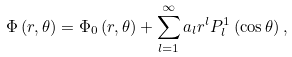<formula> <loc_0><loc_0><loc_500><loc_500>\Phi \left ( r , \theta \right ) = \Phi _ { 0 } \left ( r , \theta \right ) + \sum _ { l = 1 } ^ { \infty } a _ { l } r ^ { l } P _ { l } ^ { 1 } \left ( \cos \theta \right ) ,</formula> 